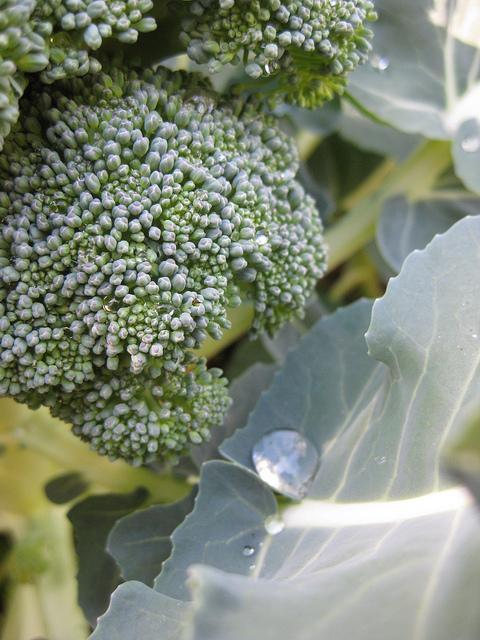How many broccolis can you see?
Give a very brief answer. 2. How many cars are in the picture?
Give a very brief answer. 0. 